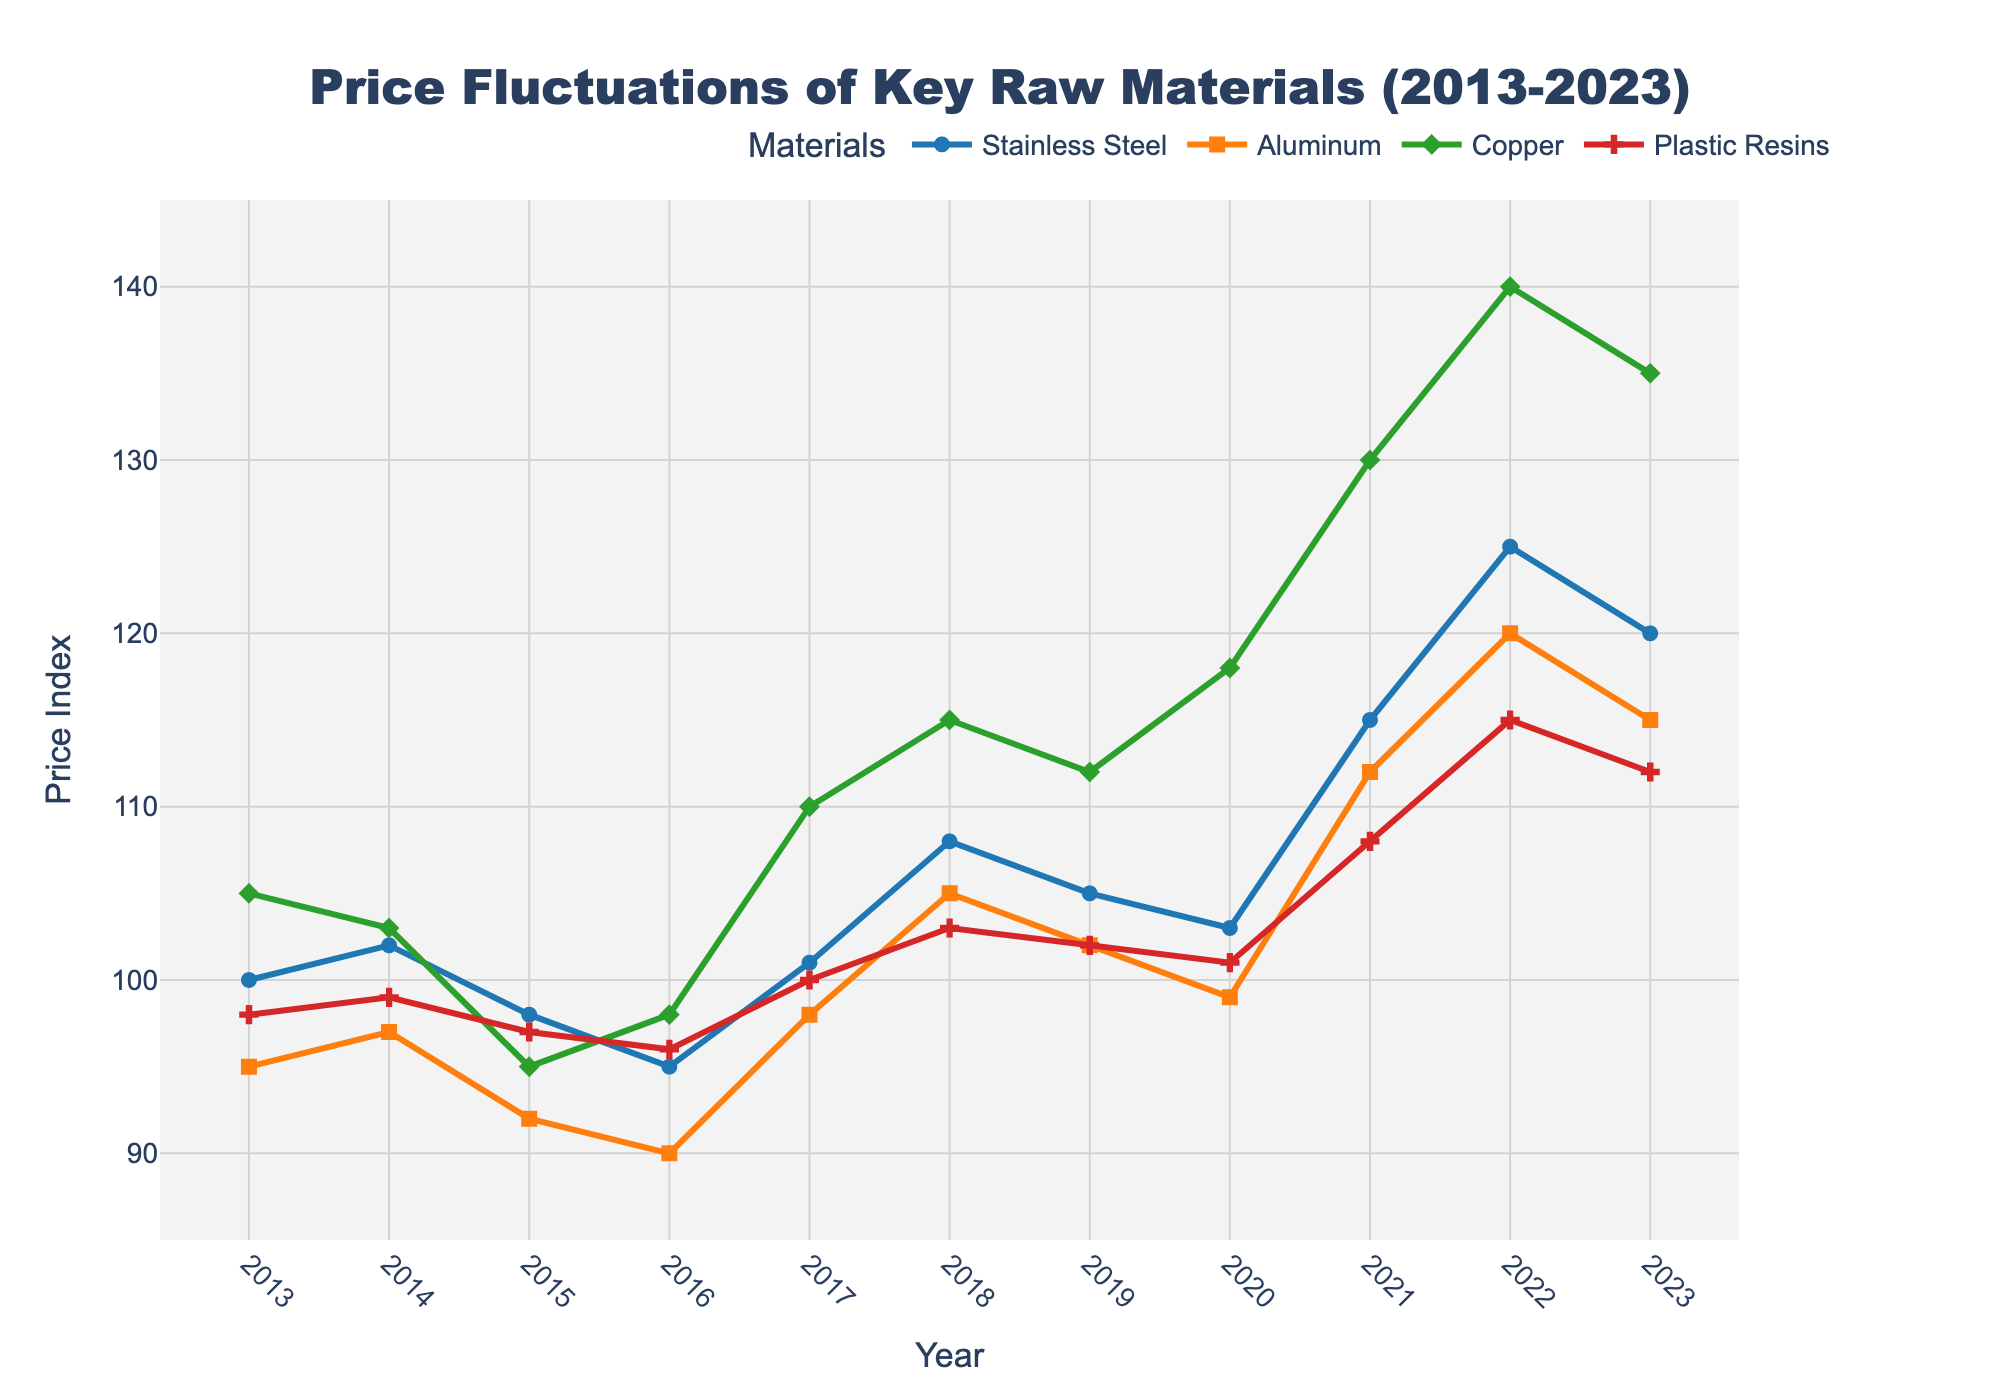Which material showed the highest price increase from 2013 to 2023? From the figure, Copper's price increased significantly from 105 in 2013 to 135 in 2023, registering the highest price increase compared to Stainless Steel, Aluminum, and Plastic Resins.
Answer: Copper How did the price of Aluminum change between 2015 and 2022? The price of Aluminum increased from 92 in 2015 to 120 in 2022. The difference is 120 - 92 = 28, indicating a rise of 28 points.
Answer: Increased by 28 points Which material had the least price variation between 2013 and 2023? To determine the material with the least fluctuation, observe the range between the maximum and minimum prices for each material over the years. Plastic Resins had a range from 96 to 115, a difference of 19 points, which is the least compared to others.
Answer: Plastic Resins In 2021, which material experienced the highest price surge compared to the previous year? Comparing the prices in 2021 and 2020, Copper's price increased from 118 to 130, an increase of 12 points, which is the highest among all materials.
Answer: Copper What was the average price of Stainless Steel from 2013 to 2023? To find the average, sum the prices of Stainless Steel from 2013 to 2023 and divide by the number of years: (100+102+98+95+101+108+105+103+115+125+120)/11 = 1063/11.
Answer: 96.6 Which year saw the highest price for Aluminum? The highest price for Aluminum, 120, is observed in 2022.
Answer: 2022 How did the prices of Copper in 2017 compare to the prices of Plastic Resins in the same year? In 2017, Copper was priced at 110, whereas Plastic Resins were priced at 100. Copper was 10 points higher than Plastic Resins.
Answer: Copper was higher by 10 points What was the trend in the price of Stainless Steel from 2013 to 2023? Stainless Steel prices exhibited an overall increasing trend over the decade, starting from 100 in 2013 and reaching 120 in 2023 with some fluctuations in between.
Answer: Increasing trend Of the four materials, which one had the highest price at any point in the dataset? Copper reached a peak price of 140 in 2022, which is the highest point observed in the dataset for all four materials.
Answer: Copper 